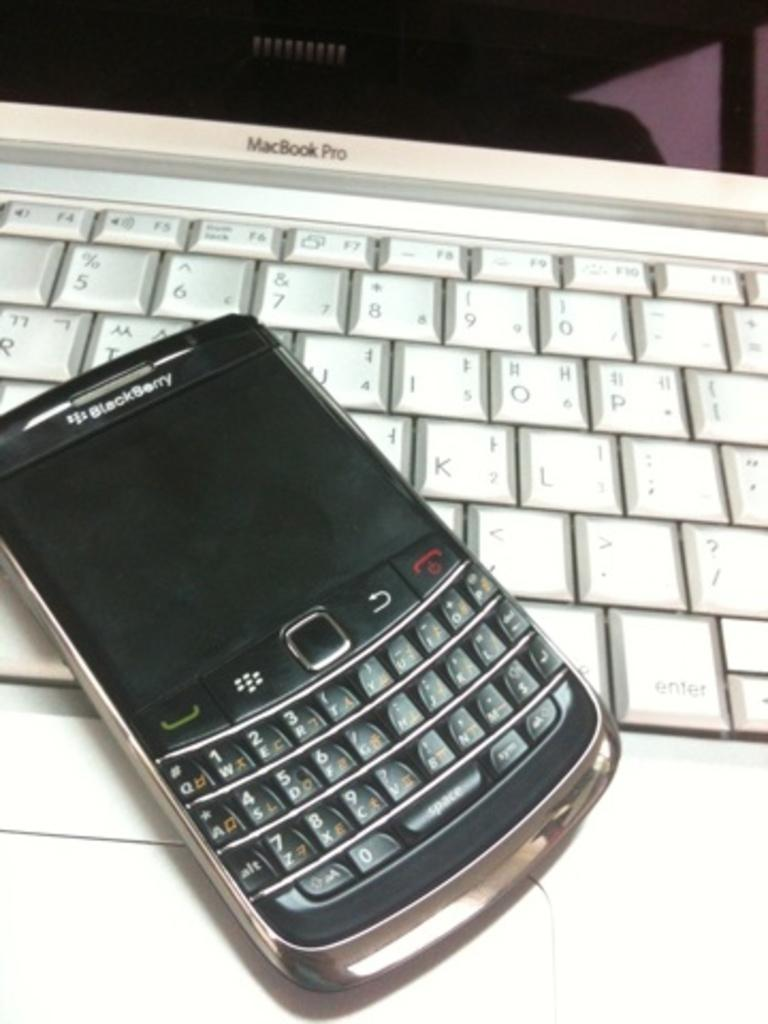What electronic device is visible in the image? There is a mobile phone in the image. What is the mobile phone placed on in the image? The mobile phone is on a laptop. Can you see any alley, sisters, or turning action in the image? No, there is no alley, sisters, or turning action present in the image. 